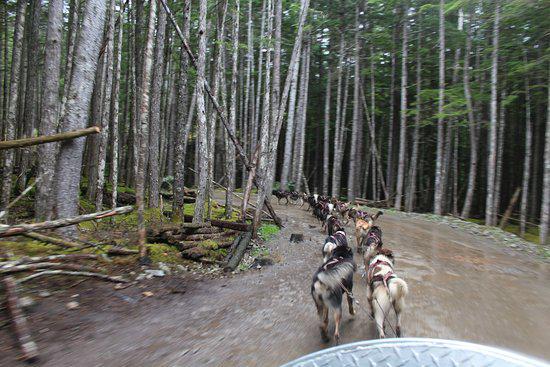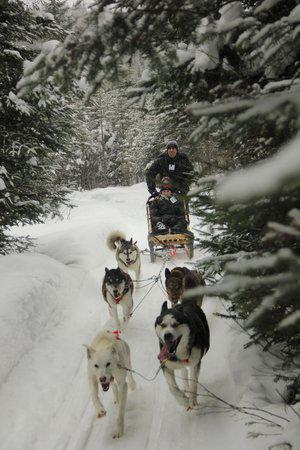The first image is the image on the left, the second image is the image on the right. Examine the images to the left and right. Is the description "In at least one image there are two adults once laying in the sled and the other holding on as at least six dogs are running right." accurate? Answer yes or no. No. The first image is the image on the left, the second image is the image on the right. For the images shown, is this caption "A dog team led by two dark dogs is racing rightward and pulling a sled with at least one passenger." true? Answer yes or no. No. 